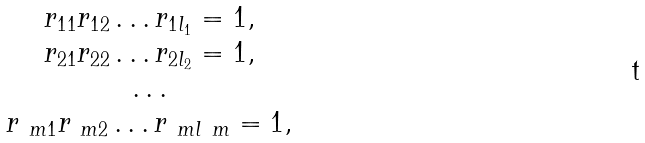Convert formula to latex. <formula><loc_0><loc_0><loc_500><loc_500>\begin{array} { c } r _ { 1 1 } r _ { 1 2 } \dots r _ { 1 l _ { 1 } } = 1 , \\ r _ { 2 1 } r _ { 2 2 } \dots r _ { 2 l _ { 2 } } = 1 , \\ \dots \\ r _ { \ m 1 } r _ { \ m 2 } \dots r _ { \ m l _ { \ } m } = 1 , \\ \end{array}</formula> 